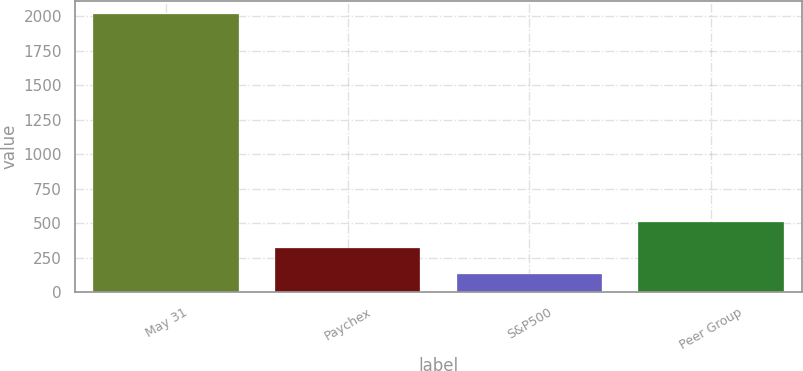Convert chart. <chart><loc_0><loc_0><loc_500><loc_500><bar_chart><fcel>May 31<fcel>Paychex<fcel>S&P500<fcel>Peer Group<nl><fcel>2015<fcel>322.7<fcel>134.67<fcel>510.73<nl></chart> 